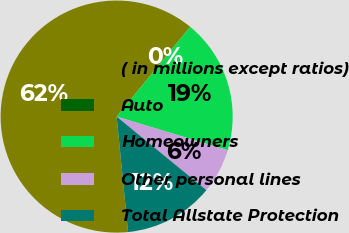Convert chart to OTSL. <chart><loc_0><loc_0><loc_500><loc_500><pie_chart><fcel>( in millions except ratios)<fcel>Auto<fcel>Homeowners<fcel>Other personal lines<fcel>Total Allstate Protection<nl><fcel>62.49%<fcel>0.01%<fcel>18.75%<fcel>6.25%<fcel>12.5%<nl></chart> 